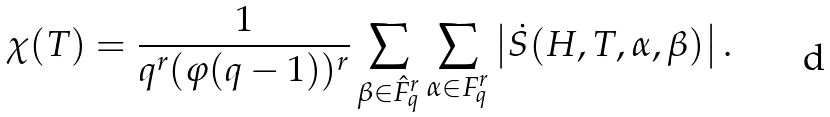Convert formula to latex. <formula><loc_0><loc_0><loc_500><loc_500>\chi ( T ) = \frac { 1 } { q ^ { r } ( \varphi ( q - 1 ) ) ^ { r } } \sum _ { \beta \in \hat { F } _ { q } ^ { r } } \sum _ { \alpha \in F _ { q } ^ { r } } \left | \dot { S } ( H , T , \alpha , \beta ) \right | .</formula> 